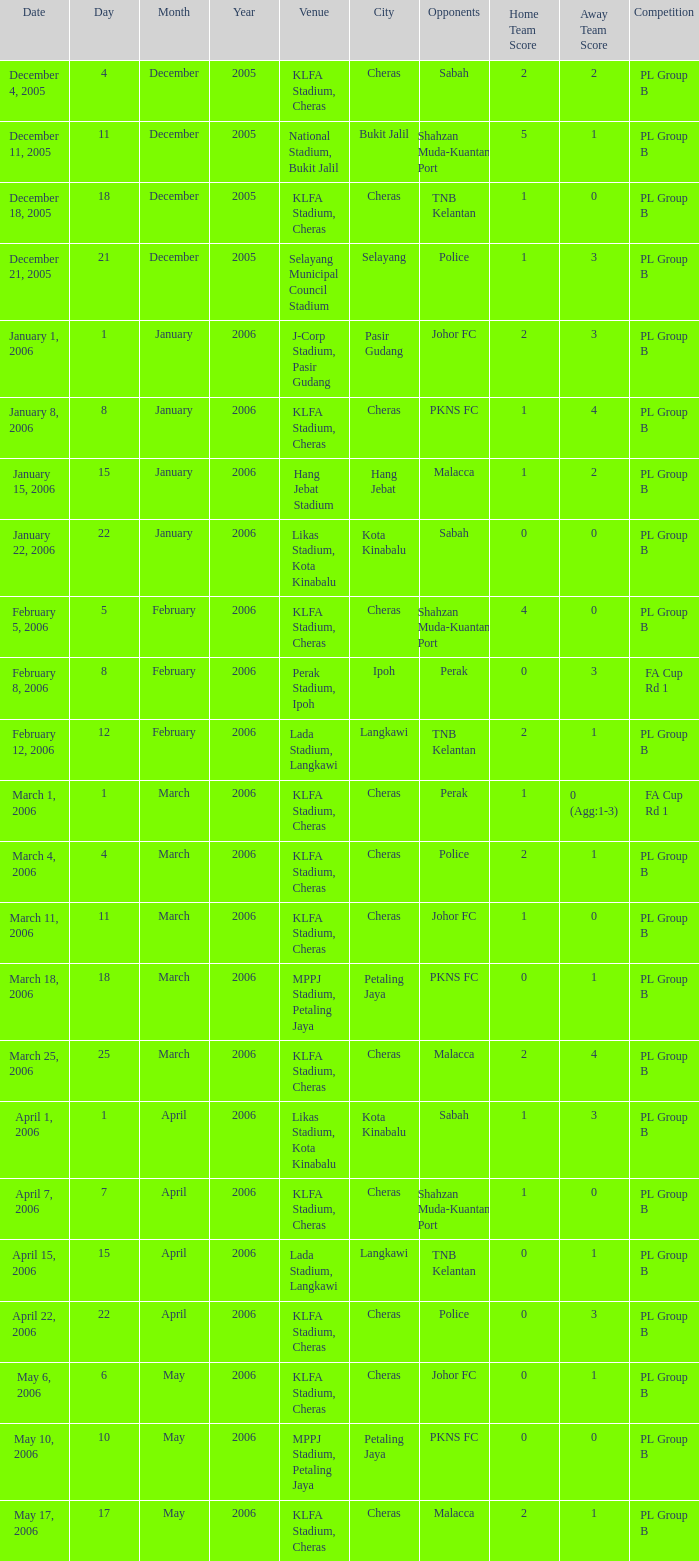Which Venue has a Competition of pl group b, and a Score of 2-2? KLFA Stadium, Cheras. 